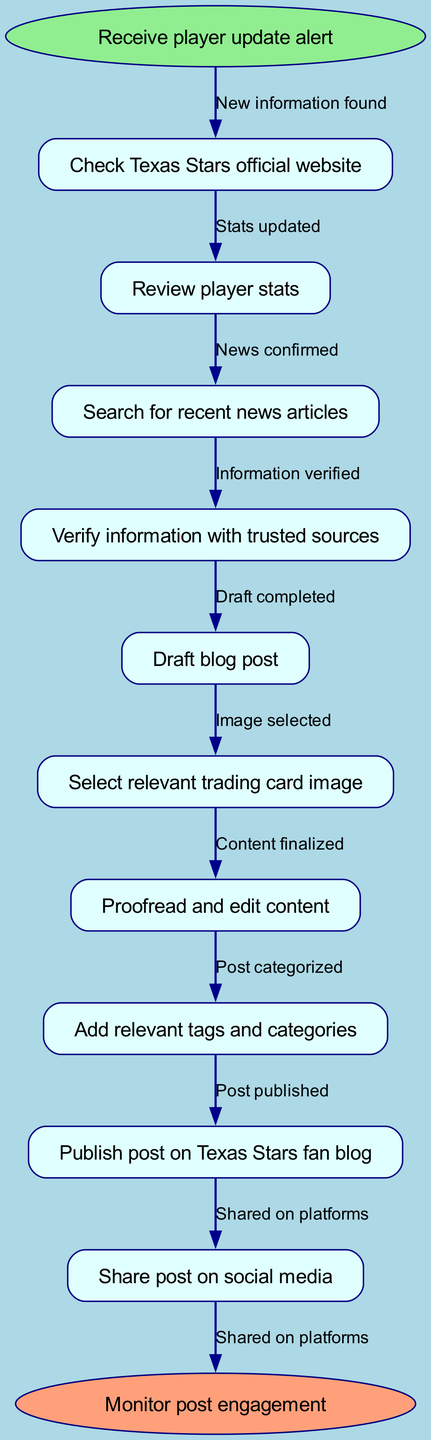What is the starting point of the process? The diagram begins with the "Receive player update alert" node as the first step in the process.
Answer: Receive player update alert How many nodes are there in total? By counting the number of process steps in the diagram, there are eleven nodes: one starting point, nine process steps, and one ending point.
Answer: eleven Which node follows "Review player stats"? The next node after "Review player stats" is "Search for recent news articles," indicating the flow of the process.
Answer: Search for recent news articles What is the last step in the process? The last step identified in the flow is "Monitor post engagement," marking the conclusion of the posting process.
Answer: Monitor post engagement What is the relationship between "Draft blog post" and "Proofread and edit content"? The edge connecting these two nodes indicates that after the "Draft blog post" is completed, the next step is to "Proofread and edit content."
Answer: Information verified What node is connected to the "Publish post on Texas Stars fan blog"? The node directly preceding "Publish post on Texas Stars fan blog" is "Add relevant tags and categories," showing the workflow that leads to publishing.
Answer: Add relevant tags and categories How many edges are there in this flow chart? There are ten edges depicted in the flow chart, representing the connections between the different nodes during the blog post creation process.
Answer: ten What step comes immediately after verifying information? Following the verification of information, the next step is to "Draft blog post," which emphasizes the sequence of actions in the process.
Answer: Draft blog post What step is undertaken after "Select relevant trading card image"? The step that comes after selecting the image is "Proofread and edit content," indicating the sequential order of tasks in creating the blog post.
Answer: Proofread and edit content 